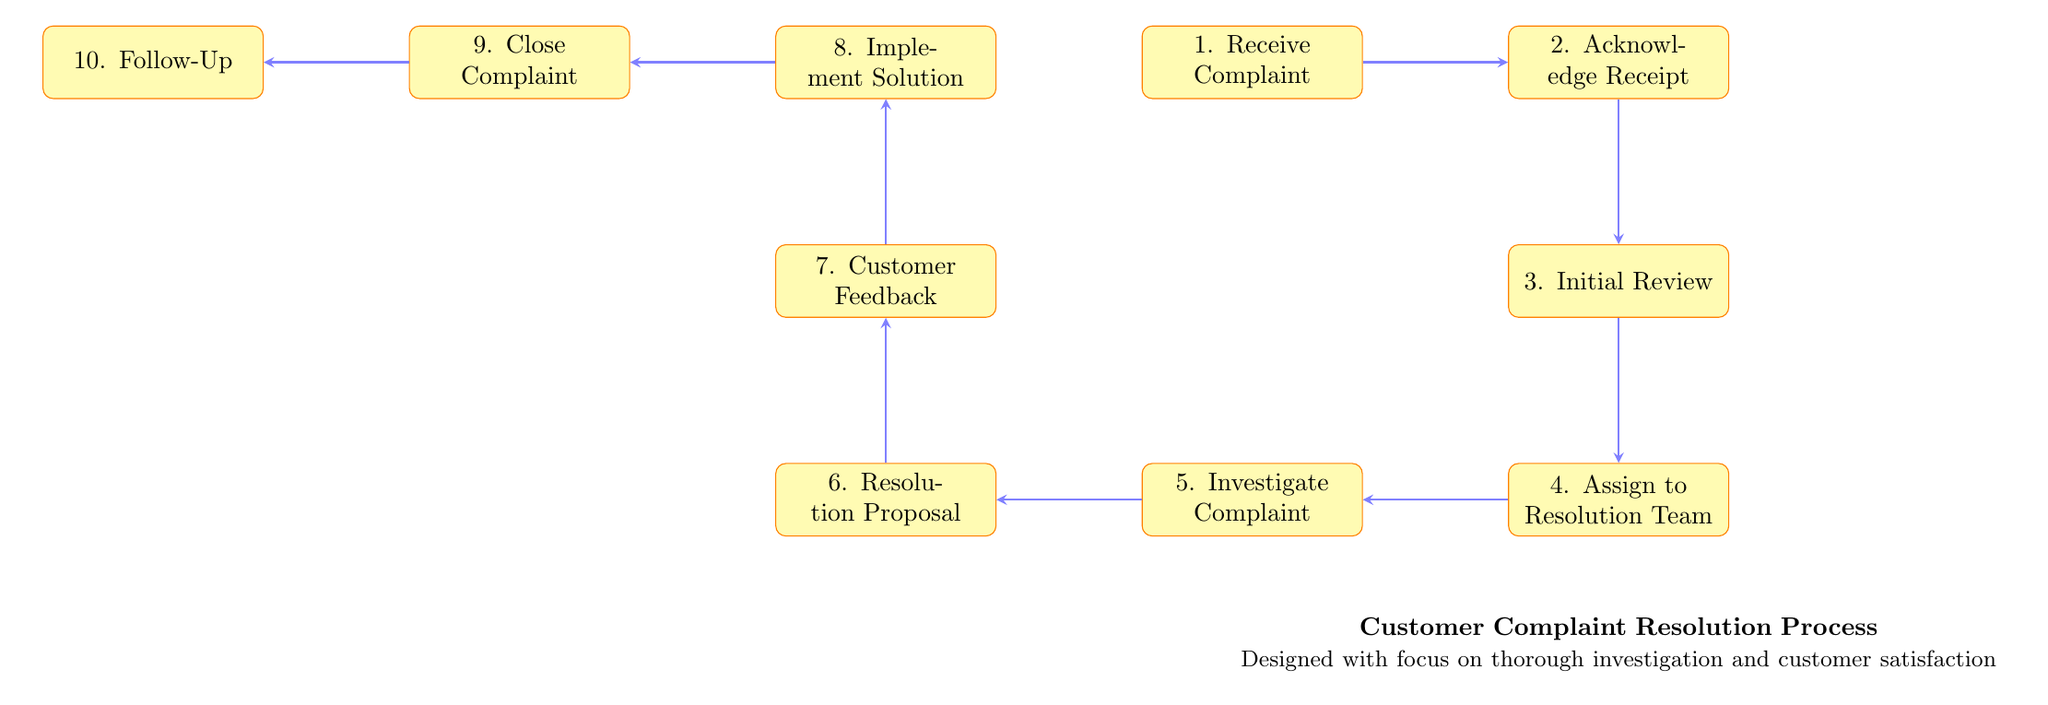What is the first step in the process? The first step in the flow chart is labeled "1. Receive Complaint," which is the starting point of the customer complaint resolution process.
Answer: Receive Complaint How many steps are there in total? By counting the numbered steps listed in the flow chart, there are ten distinct steps in the customer complaint resolution process.
Answer: Ten Which node follows "Investigate Complaint"? The node immediately following "5. Investigate Complaint" is "6. Resolution Proposal." This shows the sequential flow from one step to the next in the resolution process.
Answer: Resolution Proposal What is the last step in the process? The last step in the chart is labeled "10. Follow-Up," indicating that after closing a complaint, a follow-up occurs to ensure customer satisfaction.
Answer: Follow-Up At which step does the customer provide feedback? The customer provides feedback at step "7. Customer Feedback," where the resolution proposal is presented, and their expectations are evaluated.
Answer: Customer Feedback What step comes after "Acknowledge Receipt"? The step that comes after "2. Acknowledge Receipt" is "3. Initial Review," indicating that the process continues sequentially from acknowledgment to initial assessment.
Answer: Initial Review Which steps involve proposing a resolution? The steps that involve proposing a resolution are "6. Resolution Proposal" and can also include "7. Customer Feedback," where the customer’s opinions on the proposal are sought.
Answer: Resolution Proposal Explain the relationship between "Assign to Resolution Team" and "Investigate Complaint." "4. Assign to Resolution Team" directly leads to "5. Investigate Complaint," indicating that once a complaint is assigned to the appropriate team, they will then investigate it. This shows that investigation is a subsequent action following the assignment.
Answer: Investigate Complaint What action is taken after a solution is implemented? After the solution is implemented in step "8. Implement Solution," the next action is to officially "9. Close Complaint," which signifies the conclusion of the resolution process pending customer confirmation.
Answer: Close Complaint 